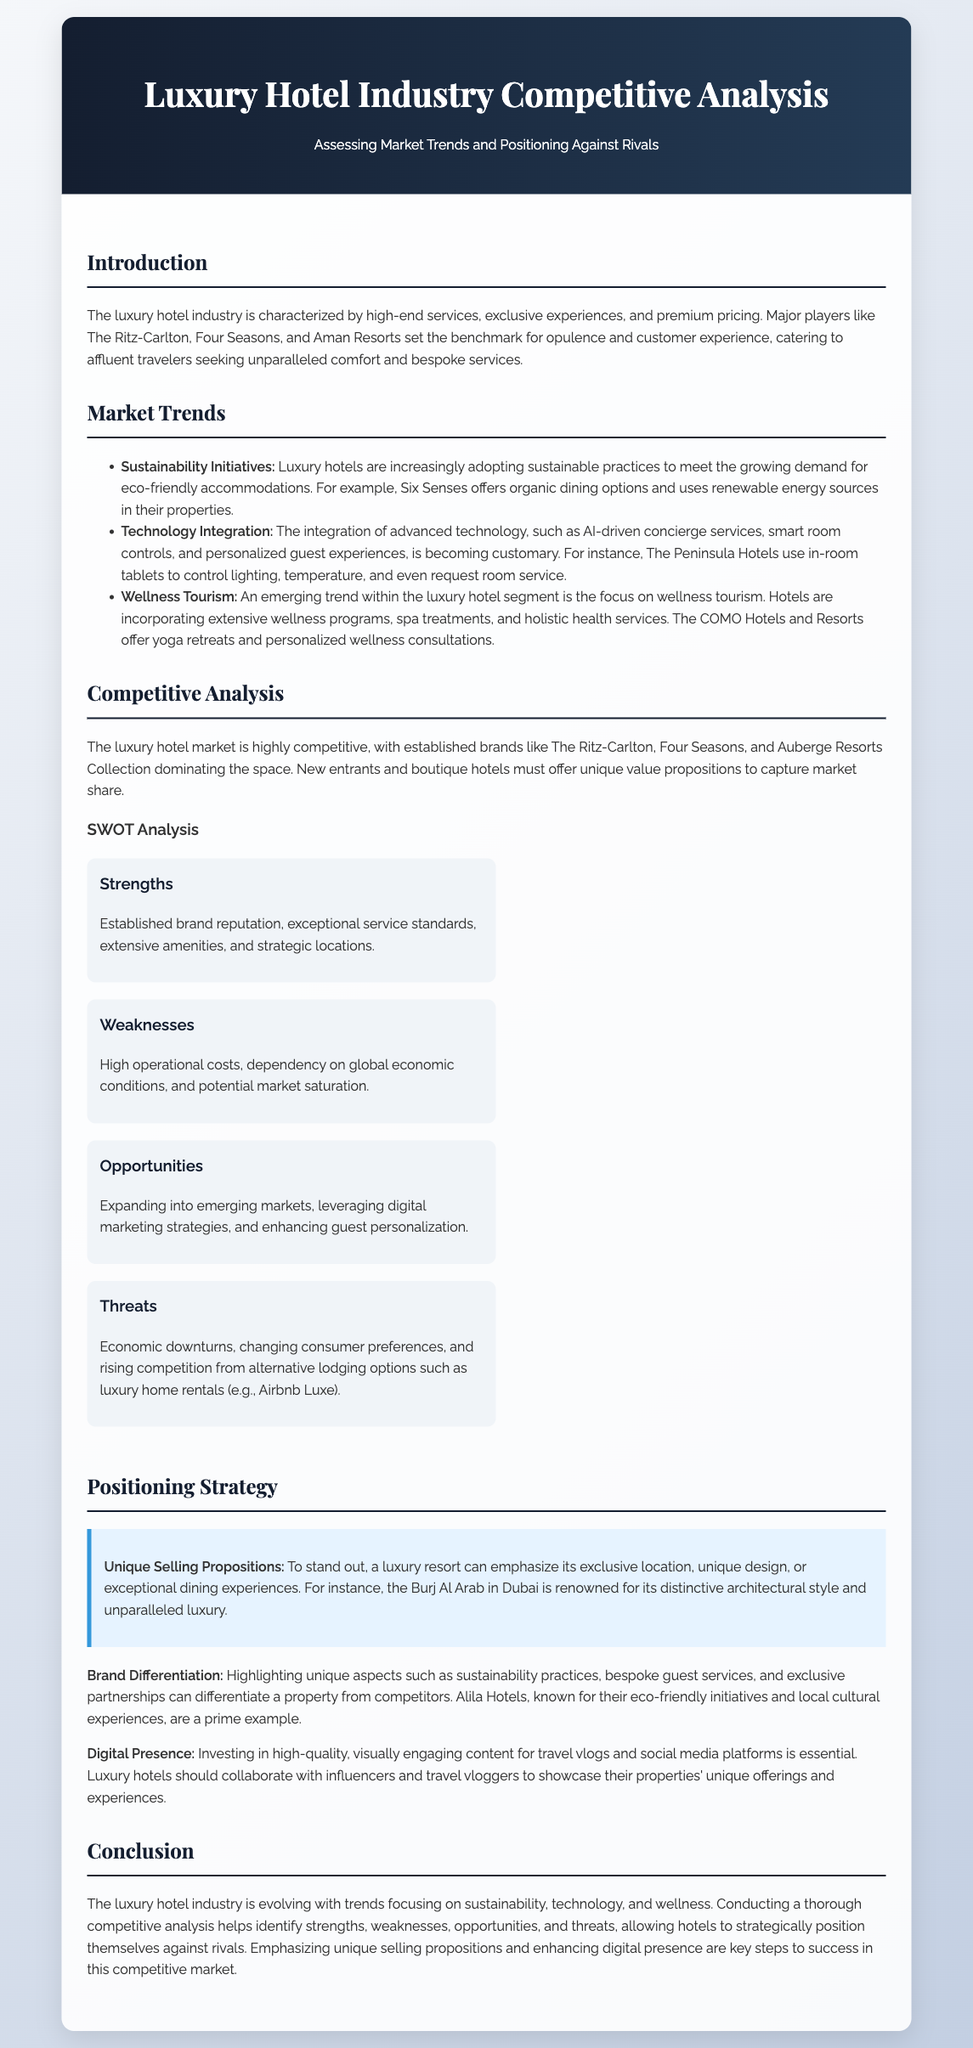What are some major players in the luxury hotel industry? The document mentions major players such as The Ritz-Carlton, Four Seasons, and Aman Resorts as benchmarks for luxury hotels.
Answer: The Ritz-Carlton, Four Seasons, Aman Resorts What is one sustainability initiative mentioned in the document? The document highlights that Six Senses offers organic dining options and uses renewable energy sources in their properties as a sustainability initiative.
Answer: Organic dining options What is identified as an emerging trend in the luxury hotel segment? Wellness tourism is noted as an emerging trend within the luxury hotel segment, focusing on wellness programs and spa treatments.
Answer: Wellness tourism What does the SWOT analysis classify as a weakness? The document states that high operational costs are classified as a weakness in the luxury hotel competitive environment.
Answer: High operational costs Which hotel's unique selling proposition is its distinctive architectural style? The Burj Al Arab in Dubai is highlighted as renowned for its distinctive architectural style and unparalleled luxury according to the document.
Answer: Burj Al Arab What kind of content investment is essential for luxury hotels? The document emphasizes the importance of investing in high-quality, visually engaging content for travel vlogs and social media platforms.
Answer: High-quality, visually engaging content What strategic focus do luxury hotels need for digital presence? Collaboration with influencers and travel vloggers is suggested as a key strategy to enhance digital presence.
Answer: Collaboration with influencers What is one of the threats to luxury hotels identified in the document? The document mentions economic downturns as a threat facing luxury hotels in the competitive landscape.
Answer: Economic downturns 